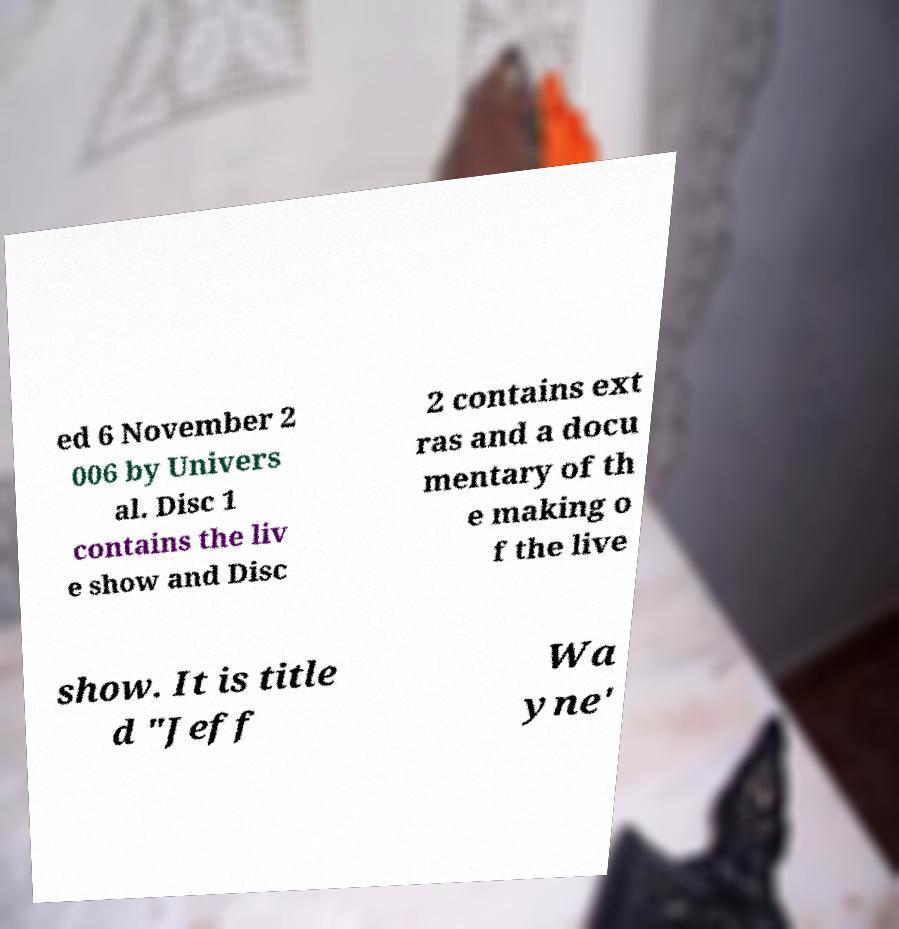Could you extract and type out the text from this image? ed 6 November 2 006 by Univers al. Disc 1 contains the liv e show and Disc 2 contains ext ras and a docu mentary of th e making o f the live show. It is title d "Jeff Wa yne' 